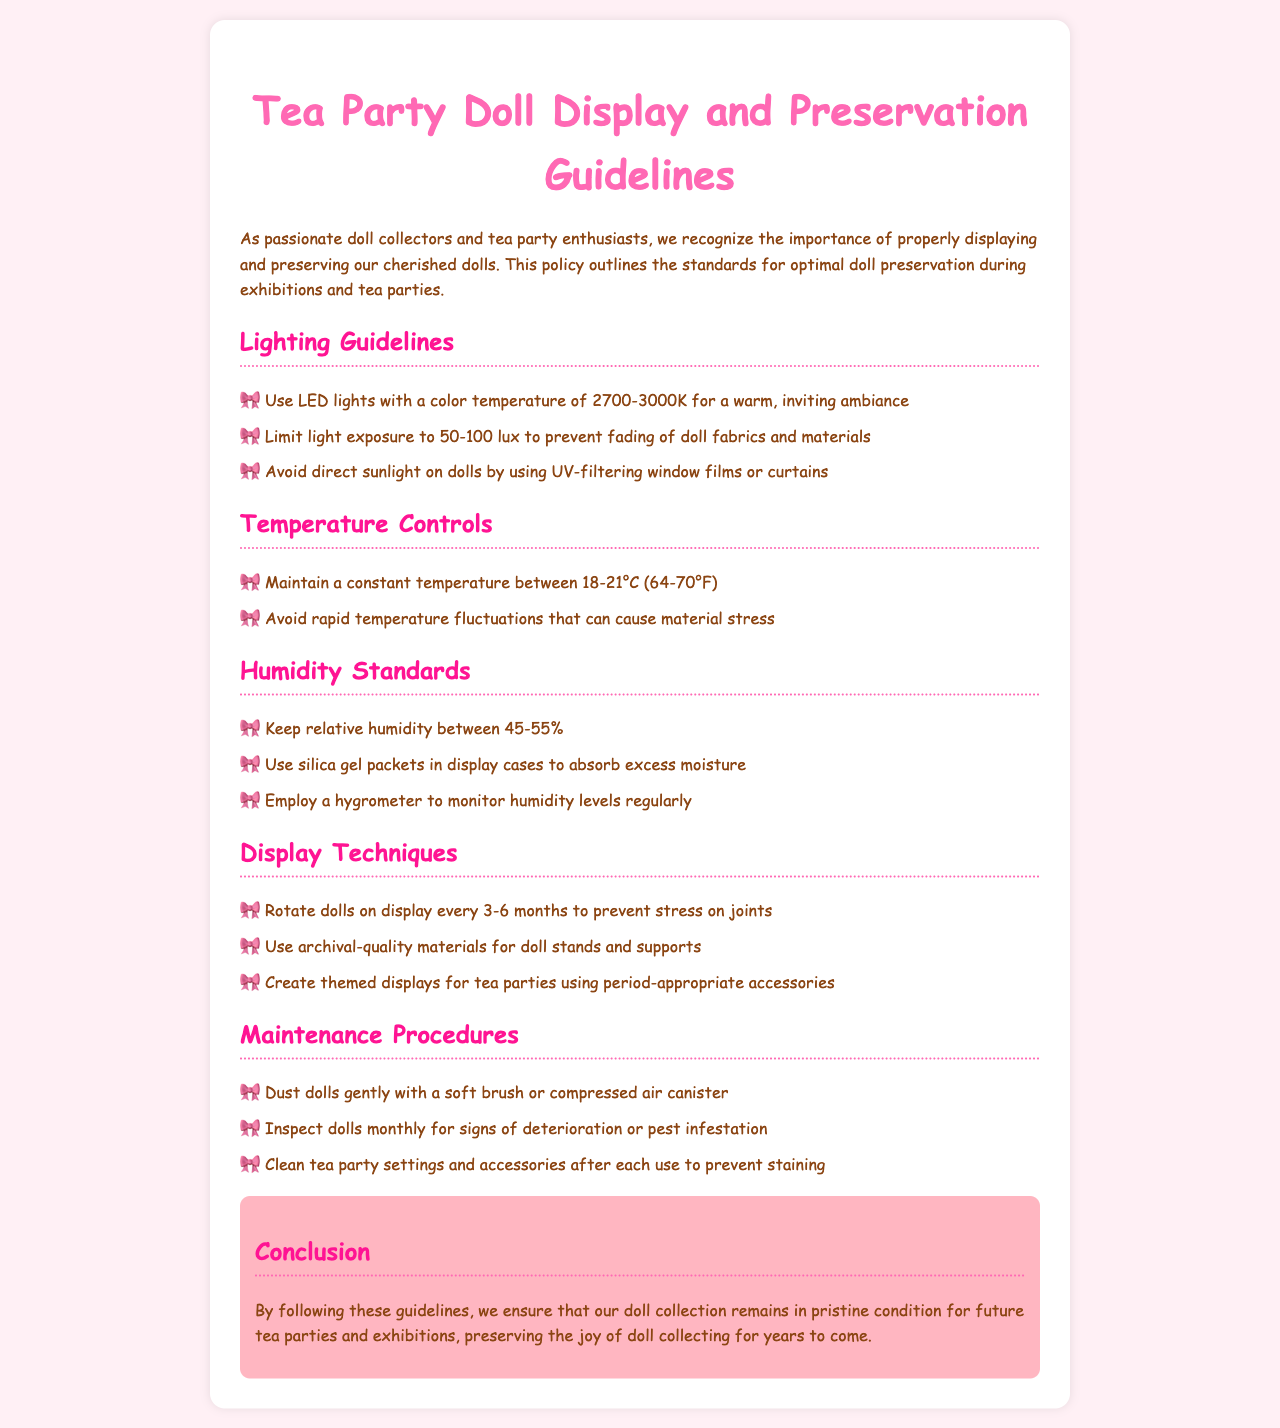What is the recommended color temperature for LED lights? The document specifies the use of LED lights with a color temperature of 2700-3000K for optimal doll display.
Answer: 2700-3000K What is the maximum light exposure in lux to prevent fading? The guidelines state to limit light exposure to a maximum of 50-100 lux to avoid fading of doll fabrics.
Answer: 50-100 lux What temperature range should be maintained for doll preservation? The document advises maintaining a constant temperature between 18-21°C (64-70°F) for preservation.
Answer: 18-21°C (64-70°F) What is the ideal relative humidity range? The guidelines recommend keeping relative humidity between 45-55% for optimal doll preservation.
Answer: 45-55% What should be used in display cases to absorb excess moisture? The document suggests using silica gel packets in display cases to control moisture levels.
Answer: Silica gel packets Why should dolls be rotated on display every 3-6 months? The reason for rotating dolls is to prevent stress on joints, as stated in the document.
Answer: Prevent stress on joints What kind of materials should be used for doll stands? The policy recommends using archival-quality materials for doll stands and supports to ensure preservation.
Answer: Archival-quality materials How often should dolls be inspected for signs of deterioration? The document states that dolls should be inspected monthly for any signs of deterioration.
Answer: Monthly What is one method to clean dolls? The guidelines suggest dusting dolls gently with a soft brush or compressed air canister.
Answer: Soft brush or compressed air What is the purpose of using themed displays at tea parties? The document encourages creating themed displays using period-appropriate accessories for enhanced aesthetic appeal.
Answer: Enhance aesthetic appeal 